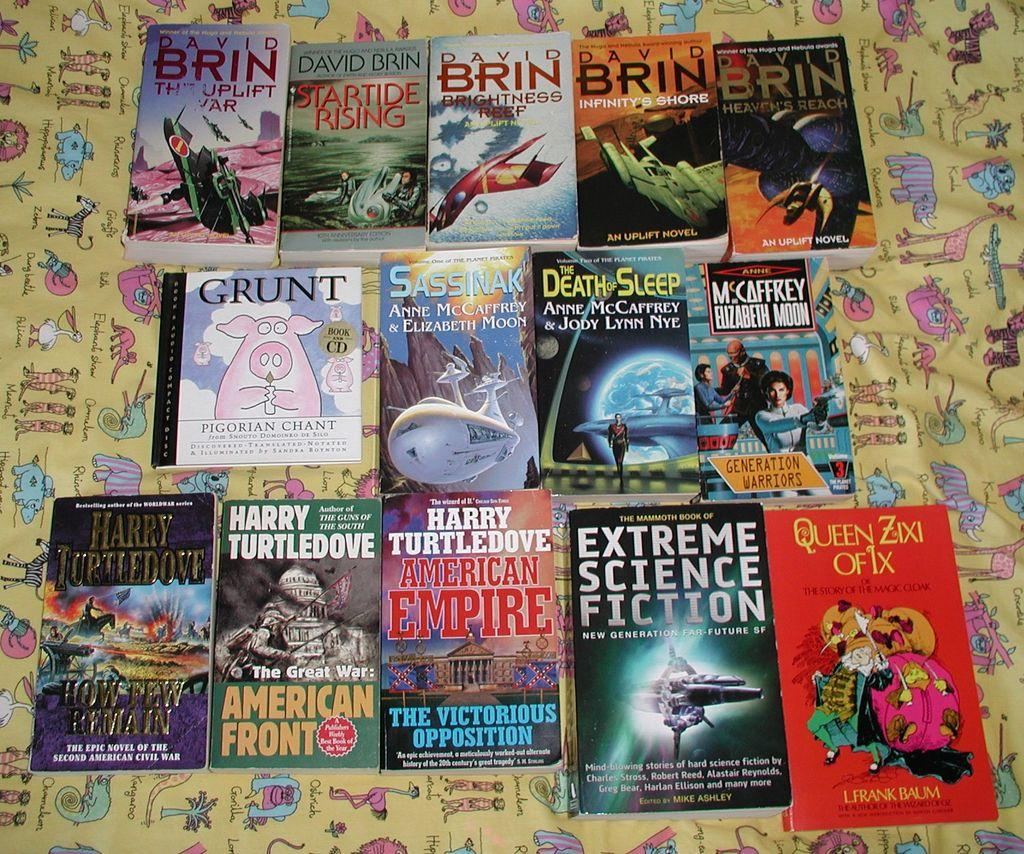<image>
Describe the image concisely. A display of books, one of which is called Death Sleep 